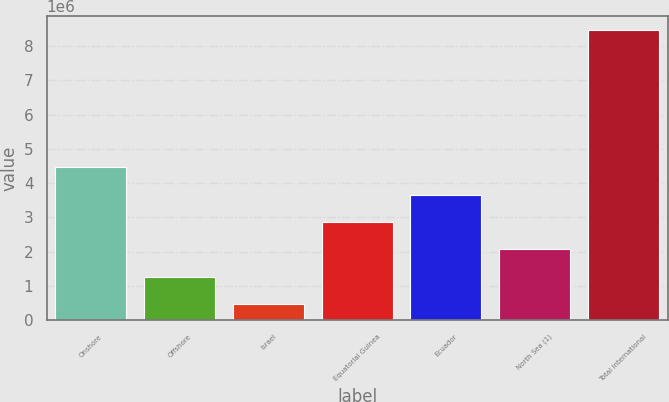<chart> <loc_0><loc_0><loc_500><loc_500><bar_chart><fcel>Onshore<fcel>Offshore<fcel>Israel<fcel>Equatorial Guinea<fcel>Ecuador<fcel>North Sea (1)<fcel>Total International<nl><fcel>4.46707e+06<fcel>1.26803e+06<fcel>468264<fcel>2.86755e+06<fcel>3.66731e+06<fcel>2.06779e+06<fcel>8.46588e+06<nl></chart> 